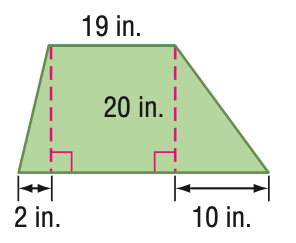Answer the mathemtical geometry problem and directly provide the correct option letter.
Question: Find the area of the trapezoid.
Choices: A: 125 B: 250 C: 500 D: 1000 C 